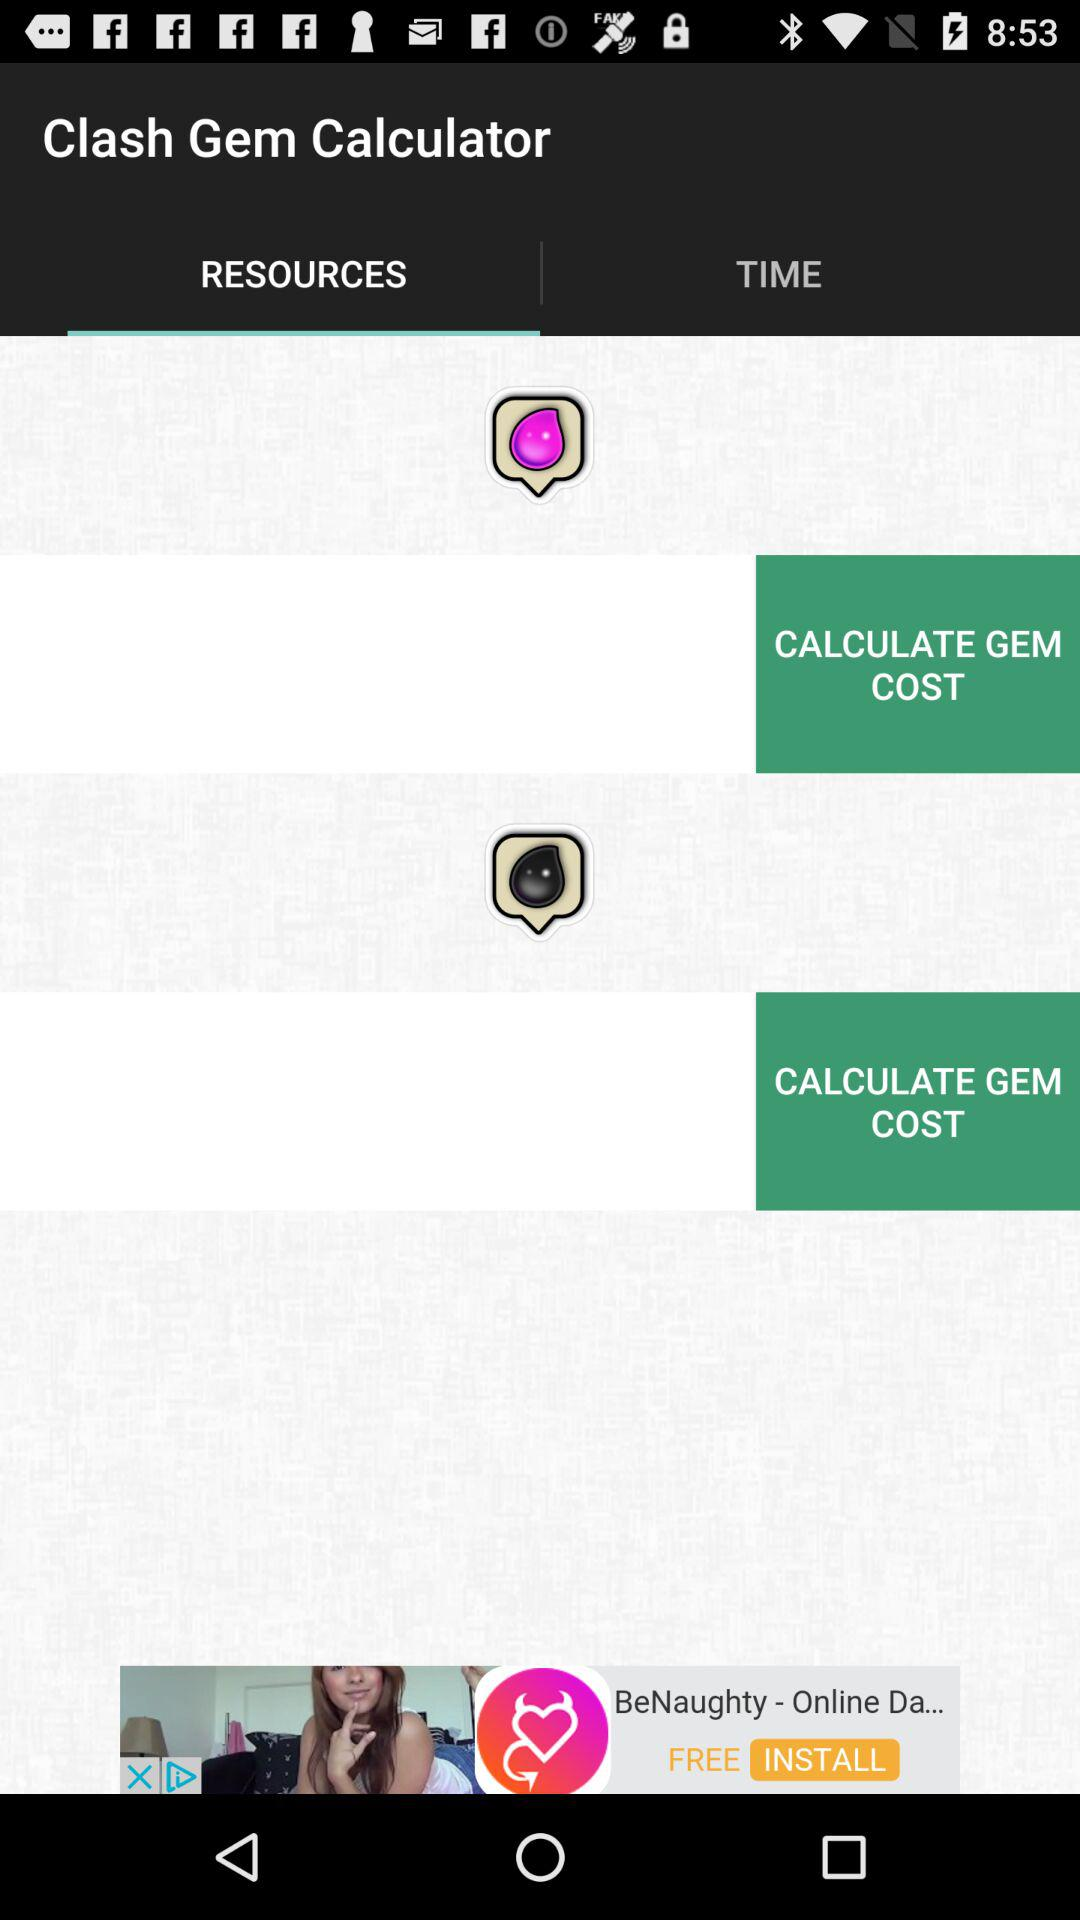Which tab is selected? The selected tab is "RESOURCES". 